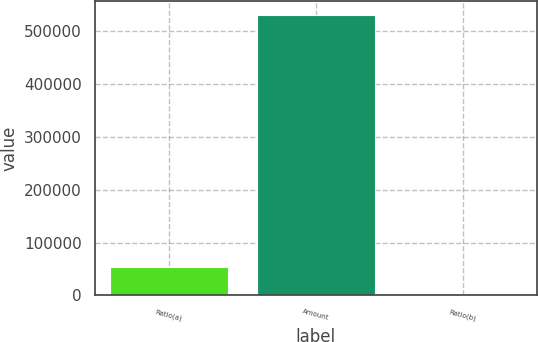Convert chart to OTSL. <chart><loc_0><loc_0><loc_500><loc_500><bar_chart><fcel>Ratio(a)<fcel>Amount<fcel>Ratio(b)<nl><fcel>53010.5<fcel>529988<fcel>13.03<nl></chart> 